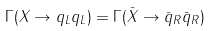<formula> <loc_0><loc_0><loc_500><loc_500>\Gamma ( X \to q _ { L } q _ { L } ) = \Gamma ( \bar { X } \to \bar { q } _ { R } \bar { q } _ { R } )</formula> 